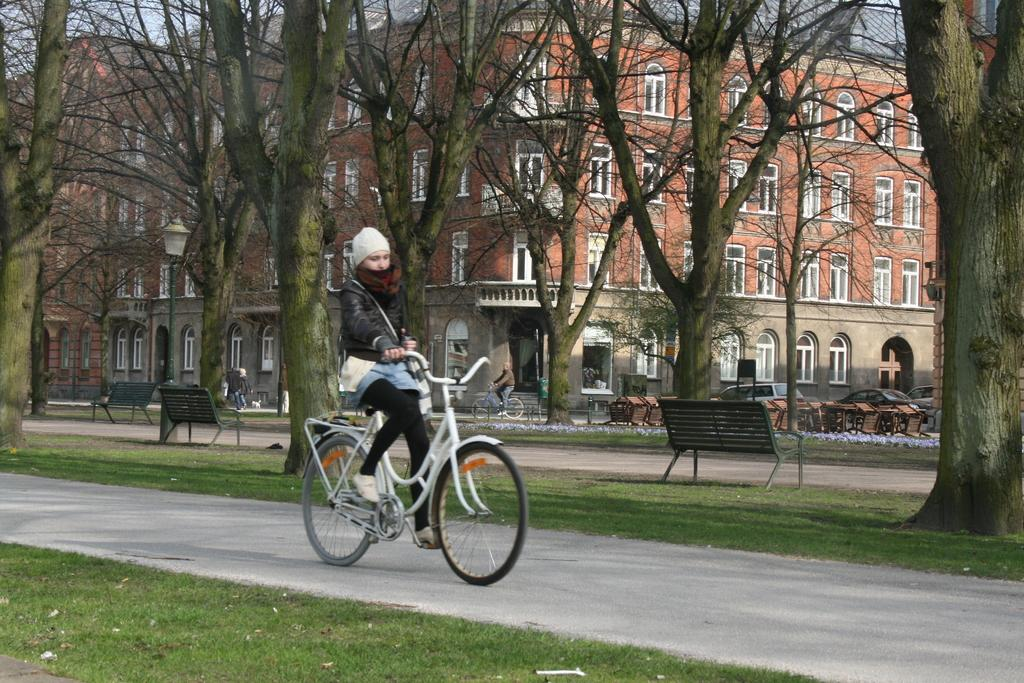What is the girl doing in the image? The girl is riding a bicycle in the image. Where is the girl riding her bicycle? The girl is on the road in the image. What can be seen near the road in the image? There are trees near the road in the image. What type of seating is present in the image? There are benches in the image. What type of location does the image appear to depict? The location appears to be a park in the image. What else is present on the road in the image? There are cars on the road in the image. What type of structure is visible in the image? There is a building visible in the image. Can you see any seashore or dock in the image? No, there is no seashore or dock present in the image. 